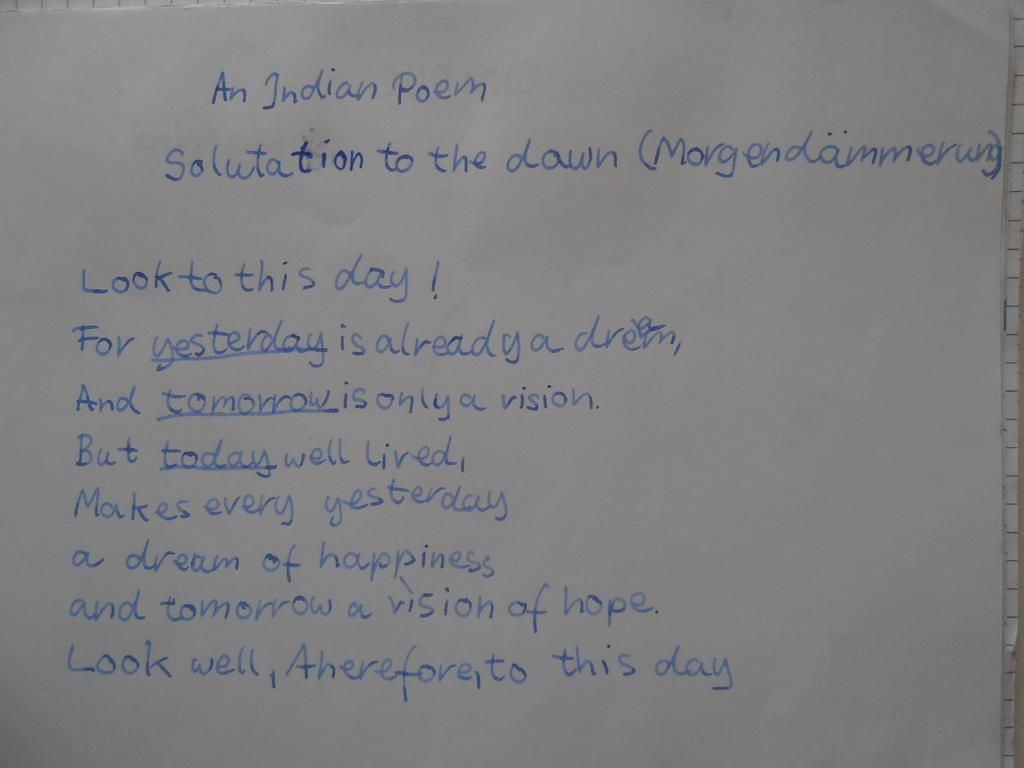<image>
Present a compact description of the photo's key features. A poem written down titled An Indian Poem 